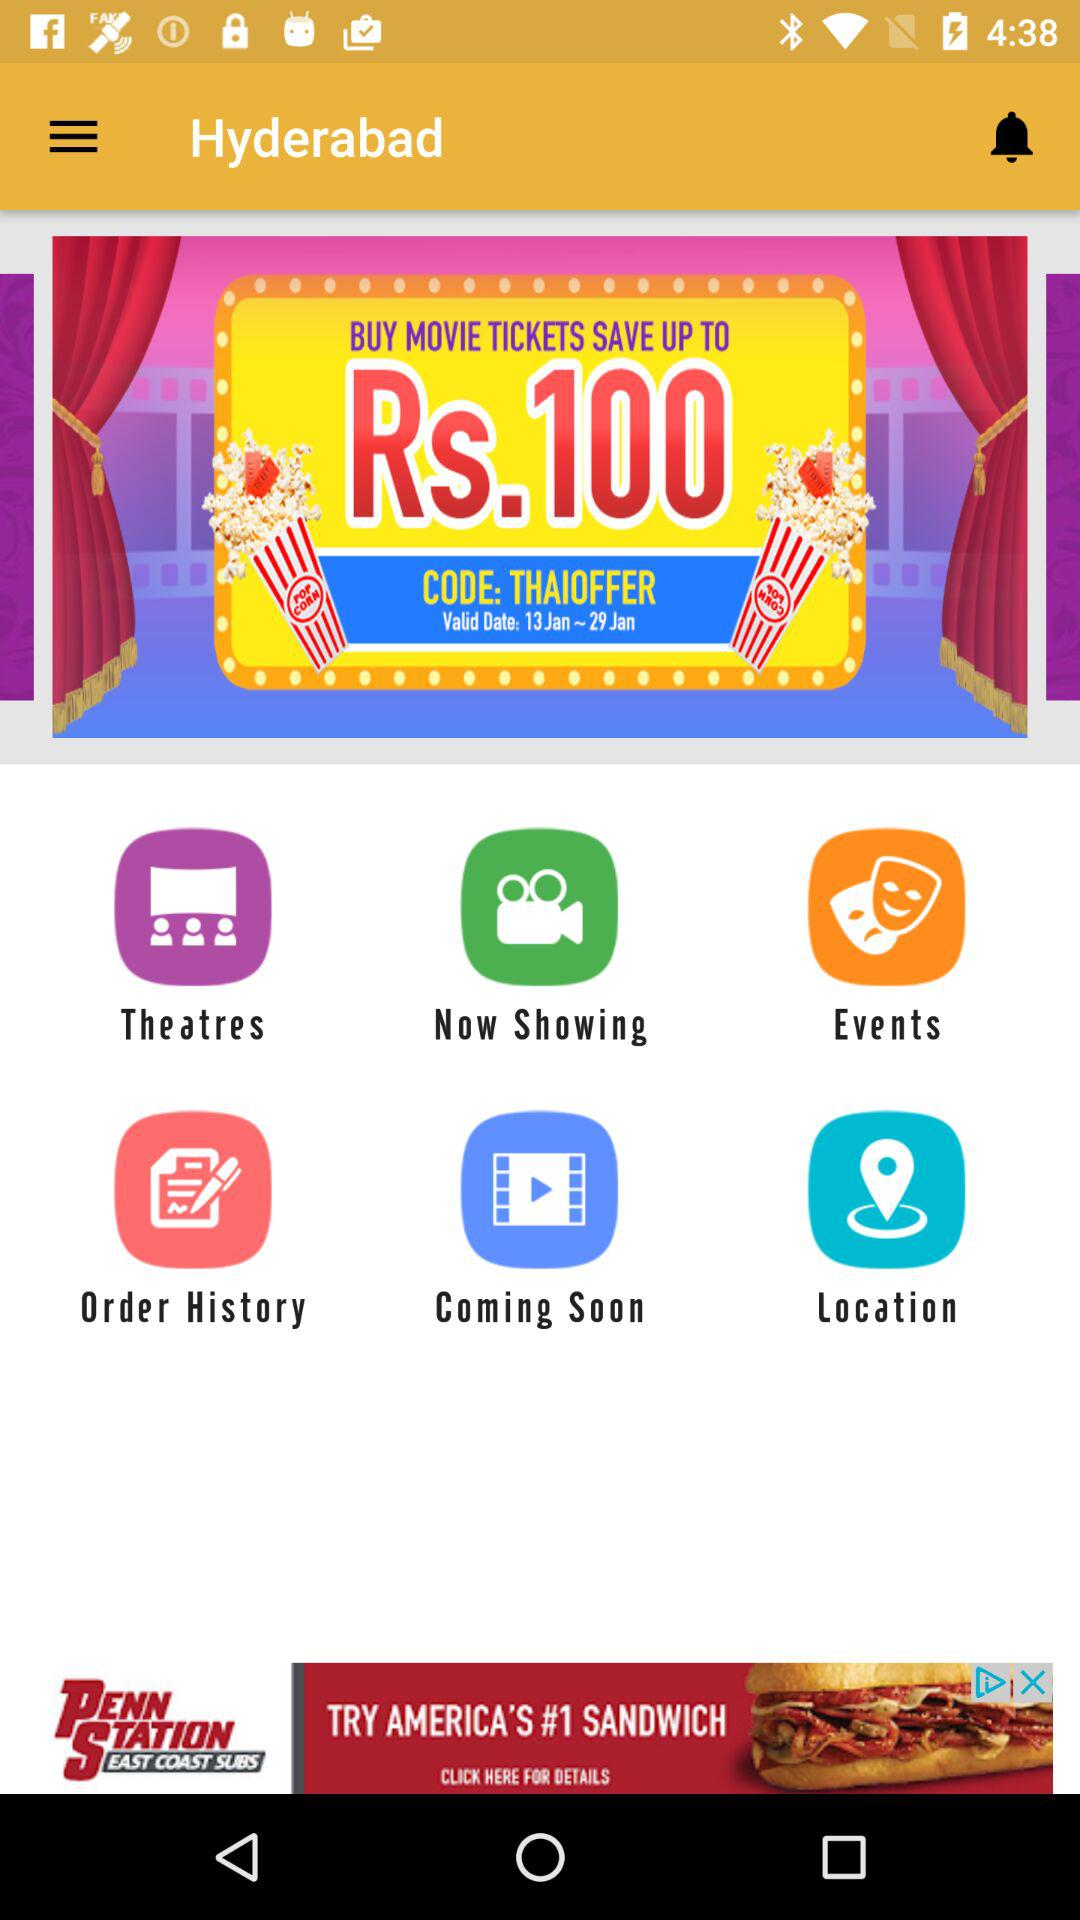How much does the Hyderabad offer save you?
Answer the question using a single word or phrase. Rs.100 